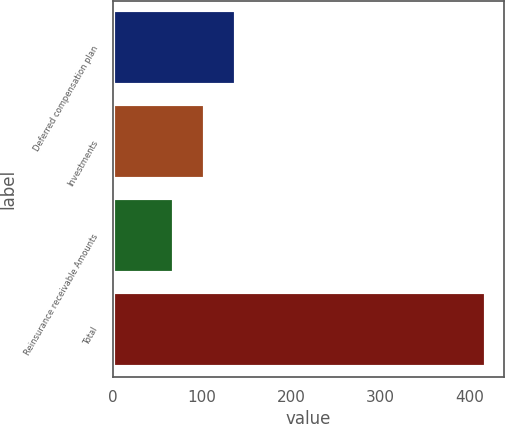Convert chart. <chart><loc_0><loc_0><loc_500><loc_500><bar_chart><fcel>Deferred compensation plan<fcel>Investments<fcel>Reinsurance receivable Amounts<fcel>Total<nl><fcel>137.96<fcel>102.98<fcel>68<fcel>417.8<nl></chart> 